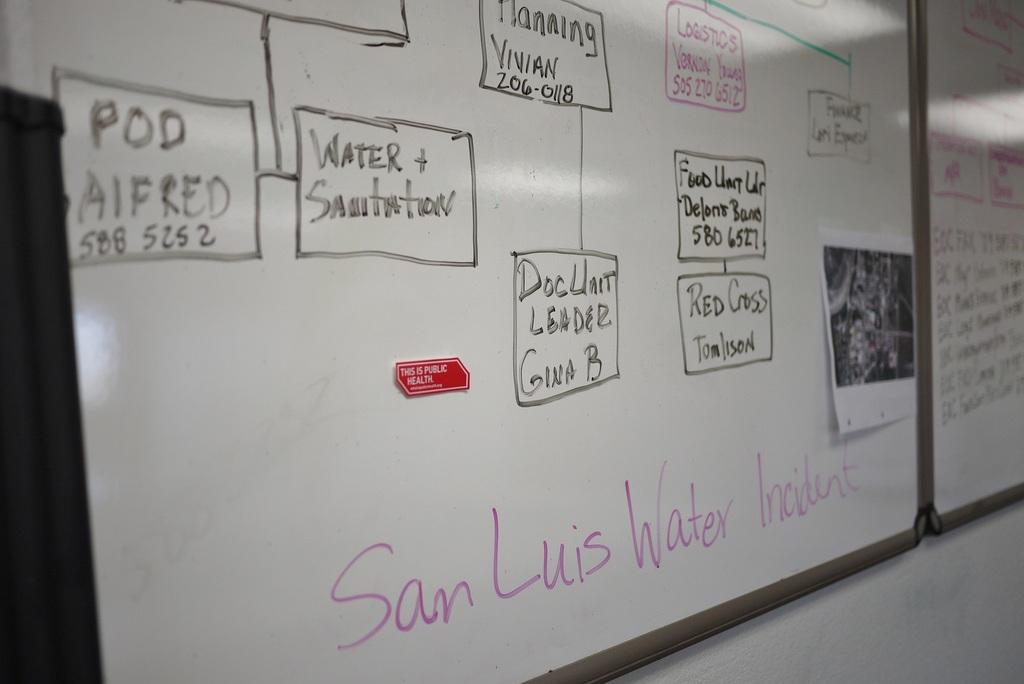Who is the doc unit leader?
Give a very brief answer. Gina b. 